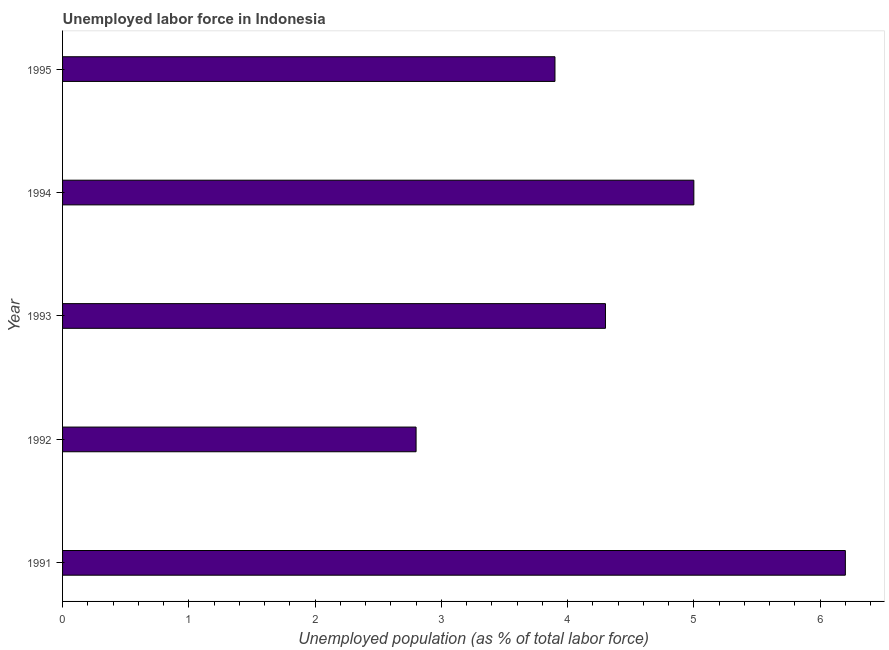Does the graph contain any zero values?
Make the answer very short. No. Does the graph contain grids?
Offer a very short reply. No. What is the title of the graph?
Provide a short and direct response. Unemployed labor force in Indonesia. What is the label or title of the X-axis?
Offer a terse response. Unemployed population (as % of total labor force). What is the label or title of the Y-axis?
Keep it short and to the point. Year. What is the total unemployed population in 1992?
Make the answer very short. 2.8. Across all years, what is the maximum total unemployed population?
Keep it short and to the point. 6.2. Across all years, what is the minimum total unemployed population?
Your answer should be compact. 2.8. What is the sum of the total unemployed population?
Offer a terse response. 22.2. What is the average total unemployed population per year?
Provide a succinct answer. 4.44. What is the median total unemployed population?
Your response must be concise. 4.3. What is the ratio of the total unemployed population in 1991 to that in 1993?
Offer a very short reply. 1.44. Is the total unemployed population in 1991 less than that in 1992?
Offer a terse response. No. Is the difference between the total unemployed population in 1993 and 1995 greater than the difference between any two years?
Offer a very short reply. No. Are all the bars in the graph horizontal?
Offer a very short reply. Yes. What is the Unemployed population (as % of total labor force) in 1991?
Give a very brief answer. 6.2. What is the Unemployed population (as % of total labor force) of 1992?
Offer a very short reply. 2.8. What is the Unemployed population (as % of total labor force) in 1993?
Offer a terse response. 4.3. What is the Unemployed population (as % of total labor force) of 1994?
Keep it short and to the point. 5. What is the Unemployed population (as % of total labor force) of 1995?
Your answer should be very brief. 3.9. What is the difference between the Unemployed population (as % of total labor force) in 1991 and 1993?
Provide a short and direct response. 1.9. What is the difference between the Unemployed population (as % of total labor force) in 1991 and 1995?
Your response must be concise. 2.3. What is the difference between the Unemployed population (as % of total labor force) in 1992 and 1993?
Keep it short and to the point. -1.5. What is the difference between the Unemployed population (as % of total labor force) in 1992 and 1995?
Provide a short and direct response. -1.1. What is the difference between the Unemployed population (as % of total labor force) in 1993 and 1994?
Provide a succinct answer. -0.7. What is the difference between the Unemployed population (as % of total labor force) in 1993 and 1995?
Offer a very short reply. 0.4. What is the difference between the Unemployed population (as % of total labor force) in 1994 and 1995?
Your answer should be very brief. 1.1. What is the ratio of the Unemployed population (as % of total labor force) in 1991 to that in 1992?
Your response must be concise. 2.21. What is the ratio of the Unemployed population (as % of total labor force) in 1991 to that in 1993?
Provide a short and direct response. 1.44. What is the ratio of the Unemployed population (as % of total labor force) in 1991 to that in 1994?
Give a very brief answer. 1.24. What is the ratio of the Unemployed population (as % of total labor force) in 1991 to that in 1995?
Keep it short and to the point. 1.59. What is the ratio of the Unemployed population (as % of total labor force) in 1992 to that in 1993?
Keep it short and to the point. 0.65. What is the ratio of the Unemployed population (as % of total labor force) in 1992 to that in 1994?
Give a very brief answer. 0.56. What is the ratio of the Unemployed population (as % of total labor force) in 1992 to that in 1995?
Your response must be concise. 0.72. What is the ratio of the Unemployed population (as % of total labor force) in 1993 to that in 1994?
Provide a short and direct response. 0.86. What is the ratio of the Unemployed population (as % of total labor force) in 1993 to that in 1995?
Provide a short and direct response. 1.1. What is the ratio of the Unemployed population (as % of total labor force) in 1994 to that in 1995?
Ensure brevity in your answer.  1.28. 